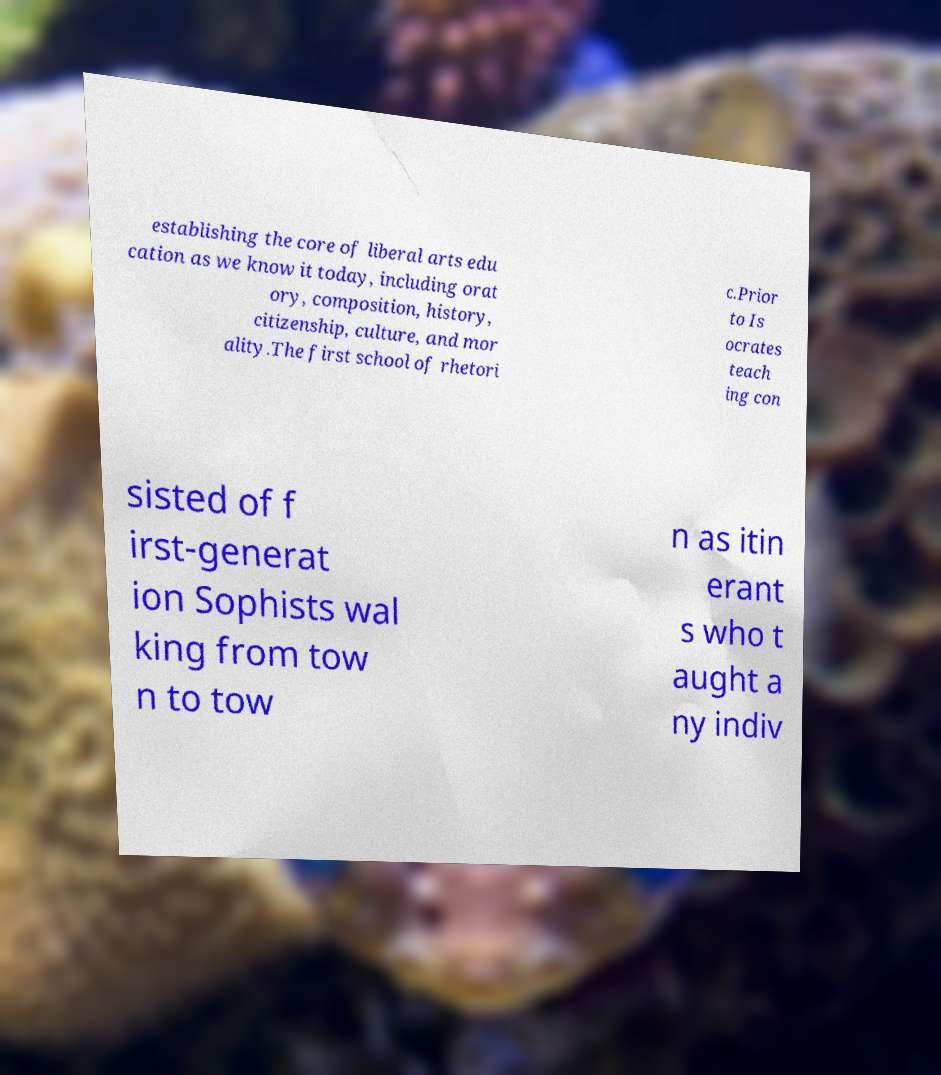Could you assist in decoding the text presented in this image and type it out clearly? establishing the core of liberal arts edu cation as we know it today, including orat ory, composition, history, citizenship, culture, and mor ality.The first school of rhetori c.Prior to Is ocrates teach ing con sisted of f irst-generat ion Sophists wal king from tow n to tow n as itin erant s who t aught a ny indiv 